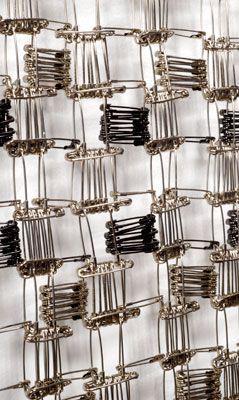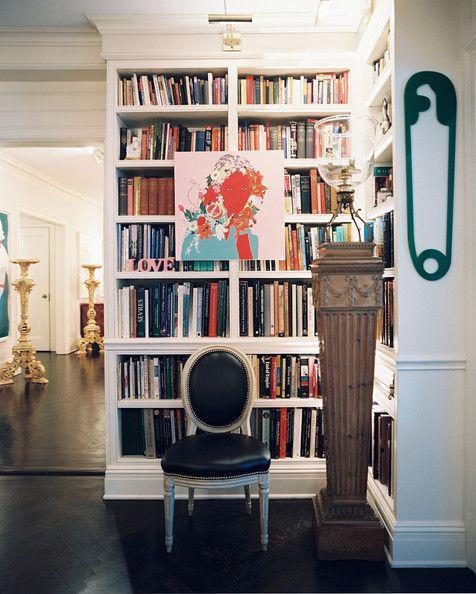The first image is the image on the left, the second image is the image on the right. Evaluate the accuracy of this statement regarding the images: "The left image shows safety pins arranged in a kind of checkerboard pattern, and the right image includes at least one vertical safety pin depiction.". Is it true? Answer yes or no. Yes. The first image is the image on the left, the second image is the image on the right. Evaluate the accuracy of this statement regarding the images: "there are 5 safety pins". Is it true? Answer yes or no. No. 